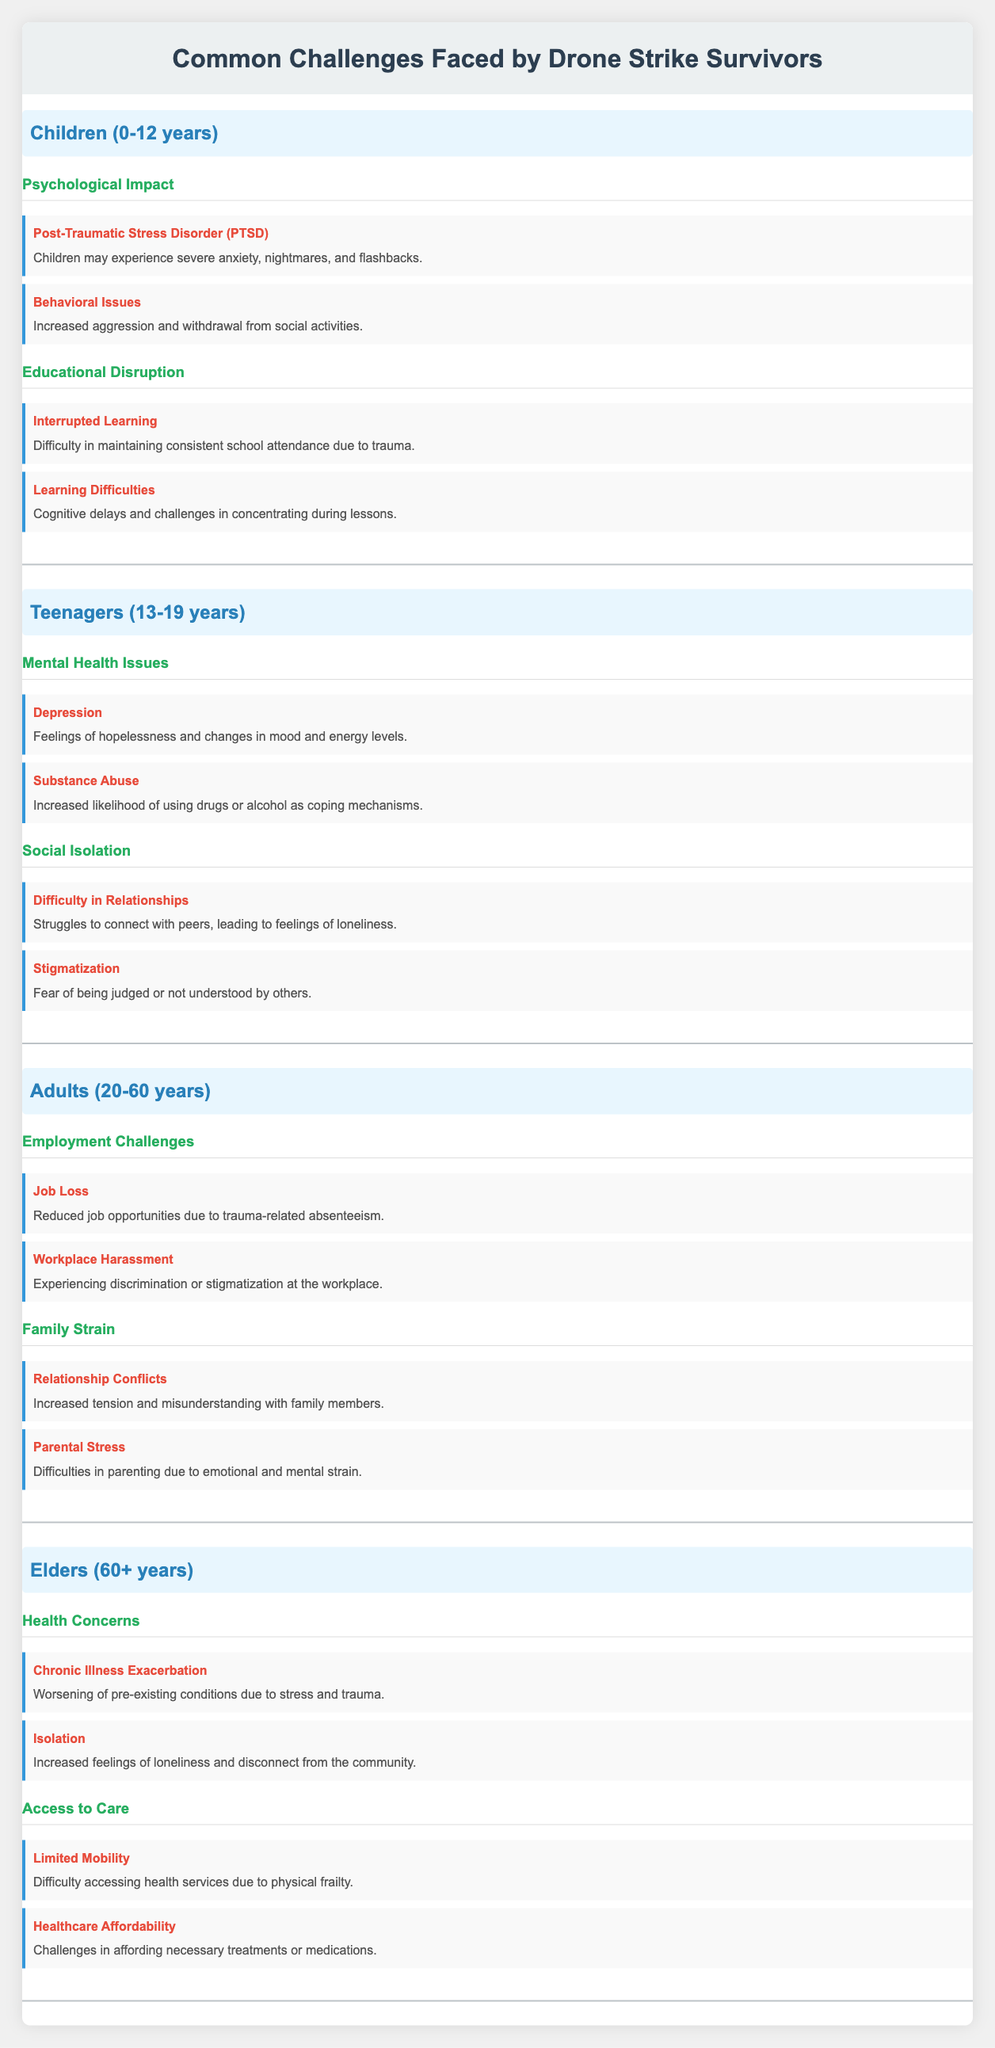What are two psychological impacts faced by children? The table lists "Psychological Impact" under the age group "Children (0-12 years)", which includes "Post-Traumatic Stress Disorder (PTSD)" and "Behavioral Issues".
Answer: Post-Traumatic Stress Disorder (PTSD) and Behavioral Issues Is "Substance Abuse" a challenge for teenagers? The table categorizes "Substance Abuse" under "Mental Health Issues" for teens, indicating it is indeed a challenge faced by that age group.
Answer: Yes How many challenges are listed under "Family Strain" for adults? The section "Family Strain" has two listed challenges: "Relationship Conflicts" and "Parental Stress". Thus, there are two challenges.
Answer: 2 Which age group is most impacted by "Chronic Illness Exacerbation"? According to the table, "Chronic Illness Exacerbation" is specifically listed under the "Health Concerns" for elders, indicating they are most impacted by this challenge.
Answer: Elders (60+ years) What is the main challenge related to educational disruption for children? The challenge "Interrupted Learning" falls under the "Educational Disruption" category for children, making it the main challenge related to education for them.
Answer: Interrupted Learning Is there a challenge related to job loss for adults? Yes, the table indicates that "Job Loss" is categorized under "Employment Challenges" for adults, confirming that this is indeed a challenge faced by them.
Answer: Yes How many challenges are identified for children compared to teenagers? The table lists four challenges for children (two under Psychological Impact and two under Educational Disruption) and four challenges for teenagers (two under Mental Health Issues and two under Social Isolation), making them equal in count.
Answer: They have an equal number of challenges (4 each) What is the common theme among challenges faced by adults? The challenges listed for adults revolve around employment and family, specifically "Employment Challenges" and "Family Strain", suggesting these are common themes for this age group.
Answer: Employment and family Which category has a challenge related to healthcare affordability? The category "Access to Care" for elders includes "Healthcare Affordability", indicating that this age group faces challenges related to access and cost of healthcare.
Answer: Access to Care 